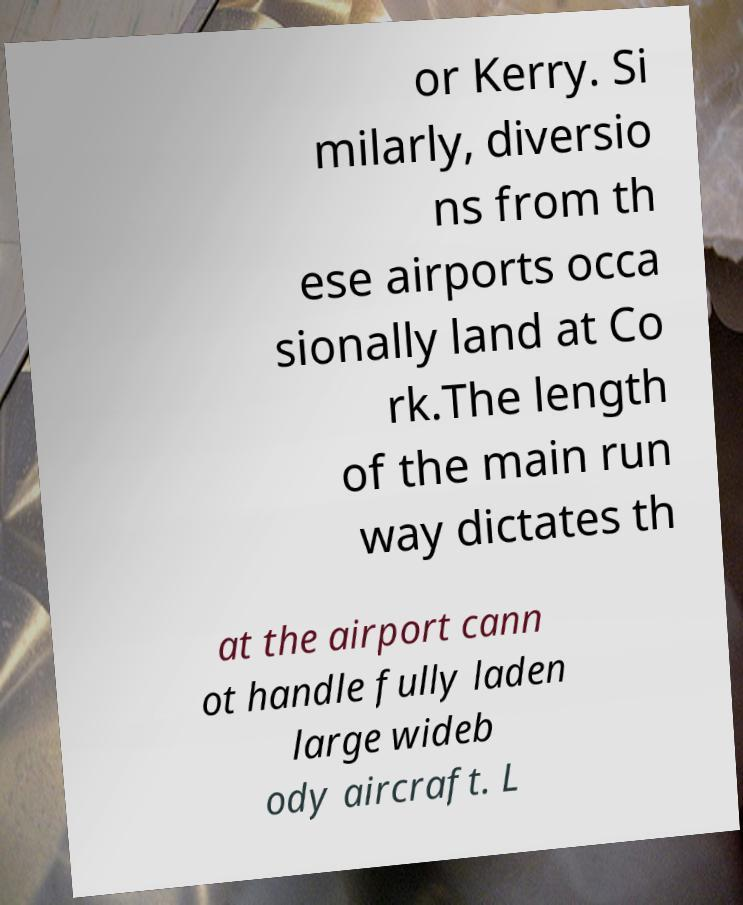There's text embedded in this image that I need extracted. Can you transcribe it verbatim? or Kerry. Si milarly, diversio ns from th ese airports occa sionally land at Co rk.The length of the main run way dictates th at the airport cann ot handle fully laden large wideb ody aircraft. L 